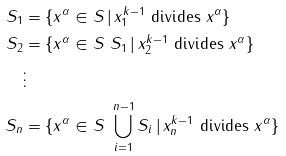<formula> <loc_0><loc_0><loc_500><loc_500>S _ { 1 } & = \{ x ^ { \alpha } \in S \, | \, x _ { 1 } ^ { k - 1 } \text { divides } x ^ { \alpha } \} \\ S _ { 2 } & = \{ x ^ { \alpha } \in S \ S _ { 1 } \, | \, x _ { 2 } ^ { k - 1 } \text { divides } x ^ { \alpha } \} \\ & \vdots \\ S _ { n } & = \{ x ^ { \alpha } \in S \ \bigcup _ { i = 1 } ^ { n - 1 } S _ { i } \, | \, x _ { n } ^ { k - 1 } \text { divides } x ^ { \alpha } \}</formula> 